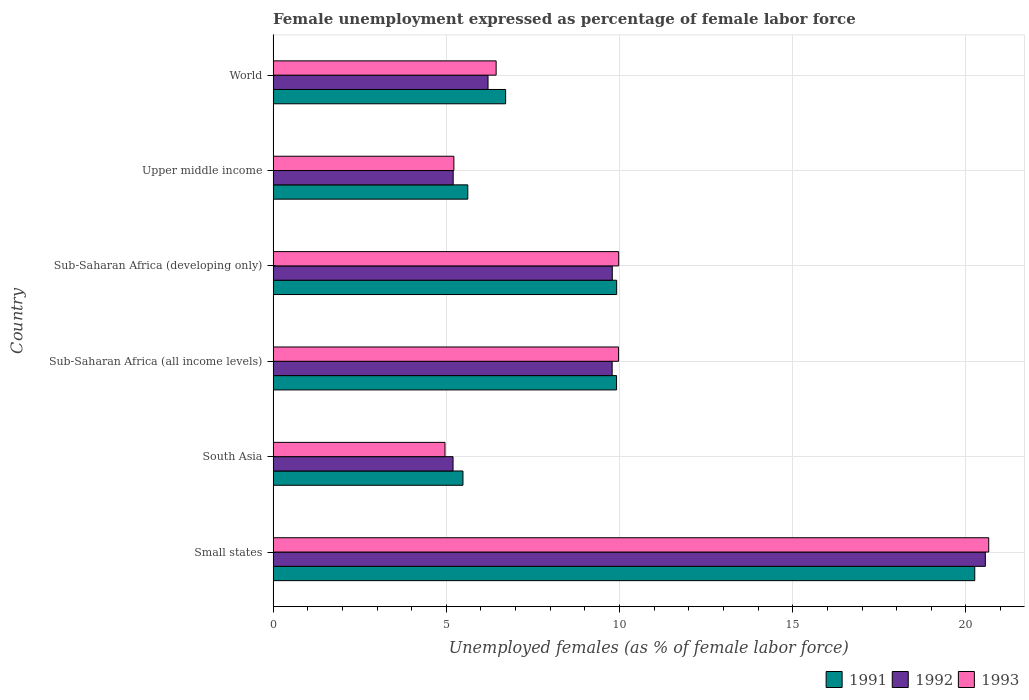Are the number of bars per tick equal to the number of legend labels?
Make the answer very short. Yes. How many bars are there on the 1st tick from the top?
Your response must be concise. 3. What is the label of the 5th group of bars from the top?
Provide a succinct answer. South Asia. In how many cases, is the number of bars for a given country not equal to the number of legend labels?
Your answer should be compact. 0. What is the unemployment in females in in 1991 in Sub-Saharan Africa (all income levels)?
Give a very brief answer. 9.91. Across all countries, what is the maximum unemployment in females in in 1992?
Keep it short and to the point. 20.56. Across all countries, what is the minimum unemployment in females in in 1993?
Offer a terse response. 4.96. In which country was the unemployment in females in in 1991 maximum?
Provide a short and direct response. Small states. What is the total unemployment in females in in 1993 in the graph?
Give a very brief answer. 57.22. What is the difference between the unemployment in females in in 1991 in South Asia and that in Sub-Saharan Africa (all income levels)?
Your response must be concise. -4.43. What is the difference between the unemployment in females in in 1993 in South Asia and the unemployment in females in in 1992 in World?
Your response must be concise. -1.24. What is the average unemployment in females in in 1993 per country?
Ensure brevity in your answer.  9.54. What is the difference between the unemployment in females in in 1993 and unemployment in females in in 1992 in Sub-Saharan Africa (all income levels)?
Your answer should be compact. 0.18. What is the ratio of the unemployment in females in in 1991 in Small states to that in Upper middle income?
Provide a short and direct response. 3.6. Is the unemployment in females in in 1993 in Sub-Saharan Africa (all income levels) less than that in Sub-Saharan Africa (developing only)?
Provide a short and direct response. Yes. What is the difference between the highest and the second highest unemployment in females in in 1993?
Give a very brief answer. 10.68. What is the difference between the highest and the lowest unemployment in females in in 1993?
Your response must be concise. 15.7. In how many countries, is the unemployment in females in in 1991 greater than the average unemployment in females in in 1991 taken over all countries?
Keep it short and to the point. 3. Is the sum of the unemployment in females in in 1991 in Sub-Saharan Africa (all income levels) and World greater than the maximum unemployment in females in in 1992 across all countries?
Provide a short and direct response. No. How many bars are there?
Offer a very short reply. 18. Are all the bars in the graph horizontal?
Ensure brevity in your answer.  Yes. What is the difference between two consecutive major ticks on the X-axis?
Offer a terse response. 5. Where does the legend appear in the graph?
Make the answer very short. Bottom right. How are the legend labels stacked?
Your answer should be very brief. Horizontal. What is the title of the graph?
Ensure brevity in your answer.  Female unemployment expressed as percentage of female labor force. Does "1992" appear as one of the legend labels in the graph?
Your answer should be compact. Yes. What is the label or title of the X-axis?
Your response must be concise. Unemployed females (as % of female labor force). What is the Unemployed females (as % of female labor force) of 1991 in Small states?
Your answer should be very brief. 20.25. What is the Unemployed females (as % of female labor force) of 1992 in Small states?
Make the answer very short. 20.56. What is the Unemployed females (as % of female labor force) in 1993 in Small states?
Your response must be concise. 20.66. What is the Unemployed females (as % of female labor force) in 1991 in South Asia?
Your answer should be very brief. 5.48. What is the Unemployed females (as % of female labor force) of 1992 in South Asia?
Keep it short and to the point. 5.19. What is the Unemployed females (as % of female labor force) in 1993 in South Asia?
Your answer should be very brief. 4.96. What is the Unemployed females (as % of female labor force) of 1991 in Sub-Saharan Africa (all income levels)?
Provide a short and direct response. 9.91. What is the Unemployed females (as % of female labor force) of 1992 in Sub-Saharan Africa (all income levels)?
Make the answer very short. 9.79. What is the Unemployed females (as % of female labor force) of 1993 in Sub-Saharan Africa (all income levels)?
Make the answer very short. 9.97. What is the Unemployed females (as % of female labor force) in 1991 in Sub-Saharan Africa (developing only)?
Offer a very short reply. 9.92. What is the Unemployed females (as % of female labor force) in 1992 in Sub-Saharan Africa (developing only)?
Give a very brief answer. 9.79. What is the Unemployed females (as % of female labor force) in 1993 in Sub-Saharan Africa (developing only)?
Make the answer very short. 9.98. What is the Unemployed females (as % of female labor force) of 1991 in Upper middle income?
Make the answer very short. 5.62. What is the Unemployed females (as % of female labor force) of 1992 in Upper middle income?
Your response must be concise. 5.2. What is the Unemployed females (as % of female labor force) of 1993 in Upper middle income?
Your response must be concise. 5.22. What is the Unemployed females (as % of female labor force) of 1991 in World?
Make the answer very short. 6.71. What is the Unemployed females (as % of female labor force) of 1992 in World?
Your answer should be very brief. 6.2. What is the Unemployed females (as % of female labor force) of 1993 in World?
Provide a short and direct response. 6.44. Across all countries, what is the maximum Unemployed females (as % of female labor force) of 1991?
Your response must be concise. 20.25. Across all countries, what is the maximum Unemployed females (as % of female labor force) in 1992?
Keep it short and to the point. 20.56. Across all countries, what is the maximum Unemployed females (as % of female labor force) of 1993?
Your answer should be compact. 20.66. Across all countries, what is the minimum Unemployed females (as % of female labor force) in 1991?
Keep it short and to the point. 5.48. Across all countries, what is the minimum Unemployed females (as % of female labor force) of 1992?
Your answer should be compact. 5.19. Across all countries, what is the minimum Unemployed females (as % of female labor force) of 1993?
Keep it short and to the point. 4.96. What is the total Unemployed females (as % of female labor force) in 1991 in the graph?
Your answer should be compact. 57.9. What is the total Unemployed females (as % of female labor force) of 1992 in the graph?
Your answer should be very brief. 56.73. What is the total Unemployed females (as % of female labor force) of 1993 in the graph?
Make the answer very short. 57.22. What is the difference between the Unemployed females (as % of female labor force) in 1991 in Small states and that in South Asia?
Ensure brevity in your answer.  14.77. What is the difference between the Unemployed females (as % of female labor force) in 1992 in Small states and that in South Asia?
Keep it short and to the point. 15.37. What is the difference between the Unemployed females (as % of female labor force) of 1993 in Small states and that in South Asia?
Provide a short and direct response. 15.7. What is the difference between the Unemployed females (as % of female labor force) in 1991 in Small states and that in Sub-Saharan Africa (all income levels)?
Offer a terse response. 10.34. What is the difference between the Unemployed females (as % of female labor force) in 1992 in Small states and that in Sub-Saharan Africa (all income levels)?
Ensure brevity in your answer.  10.77. What is the difference between the Unemployed females (as % of female labor force) of 1993 in Small states and that in Sub-Saharan Africa (all income levels)?
Provide a succinct answer. 10.69. What is the difference between the Unemployed females (as % of female labor force) of 1991 in Small states and that in Sub-Saharan Africa (developing only)?
Offer a terse response. 10.34. What is the difference between the Unemployed females (as % of female labor force) in 1992 in Small states and that in Sub-Saharan Africa (developing only)?
Provide a succinct answer. 10.77. What is the difference between the Unemployed females (as % of female labor force) in 1993 in Small states and that in Sub-Saharan Africa (developing only)?
Keep it short and to the point. 10.68. What is the difference between the Unemployed females (as % of female labor force) in 1991 in Small states and that in Upper middle income?
Your response must be concise. 14.63. What is the difference between the Unemployed females (as % of female labor force) in 1992 in Small states and that in Upper middle income?
Your answer should be very brief. 15.36. What is the difference between the Unemployed females (as % of female labor force) in 1993 in Small states and that in Upper middle income?
Offer a very short reply. 15.44. What is the difference between the Unemployed females (as % of female labor force) of 1991 in Small states and that in World?
Provide a short and direct response. 13.54. What is the difference between the Unemployed females (as % of female labor force) of 1992 in Small states and that in World?
Provide a succinct answer. 14.36. What is the difference between the Unemployed females (as % of female labor force) in 1993 in Small states and that in World?
Give a very brief answer. 14.22. What is the difference between the Unemployed females (as % of female labor force) of 1991 in South Asia and that in Sub-Saharan Africa (all income levels)?
Your answer should be compact. -4.43. What is the difference between the Unemployed females (as % of female labor force) of 1992 in South Asia and that in Sub-Saharan Africa (all income levels)?
Offer a terse response. -4.59. What is the difference between the Unemployed females (as % of female labor force) in 1993 in South Asia and that in Sub-Saharan Africa (all income levels)?
Keep it short and to the point. -5.01. What is the difference between the Unemployed females (as % of female labor force) in 1991 in South Asia and that in Sub-Saharan Africa (developing only)?
Offer a very short reply. -4.44. What is the difference between the Unemployed females (as % of female labor force) in 1992 in South Asia and that in Sub-Saharan Africa (developing only)?
Provide a succinct answer. -4.6. What is the difference between the Unemployed females (as % of female labor force) of 1993 in South Asia and that in Sub-Saharan Africa (developing only)?
Provide a succinct answer. -5.01. What is the difference between the Unemployed females (as % of female labor force) in 1991 in South Asia and that in Upper middle income?
Make the answer very short. -0.14. What is the difference between the Unemployed females (as % of female labor force) in 1992 in South Asia and that in Upper middle income?
Keep it short and to the point. -0. What is the difference between the Unemployed females (as % of female labor force) of 1993 in South Asia and that in Upper middle income?
Offer a terse response. -0.26. What is the difference between the Unemployed females (as % of female labor force) of 1991 in South Asia and that in World?
Your answer should be compact. -1.23. What is the difference between the Unemployed females (as % of female labor force) in 1992 in South Asia and that in World?
Offer a terse response. -1.01. What is the difference between the Unemployed females (as % of female labor force) of 1993 in South Asia and that in World?
Provide a short and direct response. -1.48. What is the difference between the Unemployed females (as % of female labor force) in 1991 in Sub-Saharan Africa (all income levels) and that in Sub-Saharan Africa (developing only)?
Give a very brief answer. -0. What is the difference between the Unemployed females (as % of female labor force) in 1992 in Sub-Saharan Africa (all income levels) and that in Sub-Saharan Africa (developing only)?
Your answer should be very brief. -0. What is the difference between the Unemployed females (as % of female labor force) in 1993 in Sub-Saharan Africa (all income levels) and that in Sub-Saharan Africa (developing only)?
Ensure brevity in your answer.  -0. What is the difference between the Unemployed females (as % of female labor force) of 1991 in Sub-Saharan Africa (all income levels) and that in Upper middle income?
Provide a short and direct response. 4.29. What is the difference between the Unemployed females (as % of female labor force) of 1992 in Sub-Saharan Africa (all income levels) and that in Upper middle income?
Your answer should be compact. 4.59. What is the difference between the Unemployed females (as % of female labor force) in 1993 in Sub-Saharan Africa (all income levels) and that in Upper middle income?
Your response must be concise. 4.75. What is the difference between the Unemployed females (as % of female labor force) of 1991 in Sub-Saharan Africa (all income levels) and that in World?
Ensure brevity in your answer.  3.2. What is the difference between the Unemployed females (as % of female labor force) of 1992 in Sub-Saharan Africa (all income levels) and that in World?
Your response must be concise. 3.58. What is the difference between the Unemployed females (as % of female labor force) of 1993 in Sub-Saharan Africa (all income levels) and that in World?
Offer a terse response. 3.53. What is the difference between the Unemployed females (as % of female labor force) of 1991 in Sub-Saharan Africa (developing only) and that in Upper middle income?
Offer a very short reply. 4.3. What is the difference between the Unemployed females (as % of female labor force) of 1992 in Sub-Saharan Africa (developing only) and that in Upper middle income?
Make the answer very short. 4.59. What is the difference between the Unemployed females (as % of female labor force) in 1993 in Sub-Saharan Africa (developing only) and that in Upper middle income?
Provide a short and direct response. 4.76. What is the difference between the Unemployed females (as % of female labor force) of 1991 in Sub-Saharan Africa (developing only) and that in World?
Ensure brevity in your answer.  3.21. What is the difference between the Unemployed females (as % of female labor force) in 1992 in Sub-Saharan Africa (developing only) and that in World?
Your answer should be very brief. 3.59. What is the difference between the Unemployed females (as % of female labor force) in 1993 in Sub-Saharan Africa (developing only) and that in World?
Your response must be concise. 3.54. What is the difference between the Unemployed females (as % of female labor force) in 1991 in Upper middle income and that in World?
Your response must be concise. -1.09. What is the difference between the Unemployed females (as % of female labor force) in 1992 in Upper middle income and that in World?
Your answer should be very brief. -1.01. What is the difference between the Unemployed females (as % of female labor force) in 1993 in Upper middle income and that in World?
Offer a terse response. -1.22. What is the difference between the Unemployed females (as % of female labor force) of 1991 in Small states and the Unemployed females (as % of female labor force) of 1992 in South Asia?
Keep it short and to the point. 15.06. What is the difference between the Unemployed females (as % of female labor force) of 1991 in Small states and the Unemployed females (as % of female labor force) of 1993 in South Asia?
Keep it short and to the point. 15.29. What is the difference between the Unemployed females (as % of female labor force) of 1992 in Small states and the Unemployed females (as % of female labor force) of 1993 in South Asia?
Make the answer very short. 15.6. What is the difference between the Unemployed females (as % of female labor force) of 1991 in Small states and the Unemployed females (as % of female labor force) of 1992 in Sub-Saharan Africa (all income levels)?
Your answer should be compact. 10.47. What is the difference between the Unemployed females (as % of female labor force) of 1991 in Small states and the Unemployed females (as % of female labor force) of 1993 in Sub-Saharan Africa (all income levels)?
Make the answer very short. 10.28. What is the difference between the Unemployed females (as % of female labor force) in 1992 in Small states and the Unemployed females (as % of female labor force) in 1993 in Sub-Saharan Africa (all income levels)?
Provide a succinct answer. 10.59. What is the difference between the Unemployed females (as % of female labor force) of 1991 in Small states and the Unemployed females (as % of female labor force) of 1992 in Sub-Saharan Africa (developing only)?
Provide a succinct answer. 10.46. What is the difference between the Unemployed females (as % of female labor force) in 1991 in Small states and the Unemployed females (as % of female labor force) in 1993 in Sub-Saharan Africa (developing only)?
Provide a short and direct response. 10.28. What is the difference between the Unemployed females (as % of female labor force) in 1992 in Small states and the Unemployed females (as % of female labor force) in 1993 in Sub-Saharan Africa (developing only)?
Your answer should be very brief. 10.58. What is the difference between the Unemployed females (as % of female labor force) of 1991 in Small states and the Unemployed females (as % of female labor force) of 1992 in Upper middle income?
Give a very brief answer. 15.06. What is the difference between the Unemployed females (as % of female labor force) in 1991 in Small states and the Unemployed females (as % of female labor force) in 1993 in Upper middle income?
Provide a short and direct response. 15.04. What is the difference between the Unemployed females (as % of female labor force) of 1992 in Small states and the Unemployed females (as % of female labor force) of 1993 in Upper middle income?
Provide a succinct answer. 15.34. What is the difference between the Unemployed females (as % of female labor force) in 1991 in Small states and the Unemployed females (as % of female labor force) in 1992 in World?
Keep it short and to the point. 14.05. What is the difference between the Unemployed females (as % of female labor force) in 1991 in Small states and the Unemployed females (as % of female labor force) in 1993 in World?
Your answer should be very brief. 13.82. What is the difference between the Unemployed females (as % of female labor force) in 1992 in Small states and the Unemployed females (as % of female labor force) in 1993 in World?
Keep it short and to the point. 14.12. What is the difference between the Unemployed females (as % of female labor force) of 1991 in South Asia and the Unemployed females (as % of female labor force) of 1992 in Sub-Saharan Africa (all income levels)?
Your response must be concise. -4.31. What is the difference between the Unemployed females (as % of female labor force) of 1991 in South Asia and the Unemployed females (as % of female labor force) of 1993 in Sub-Saharan Africa (all income levels)?
Ensure brevity in your answer.  -4.49. What is the difference between the Unemployed females (as % of female labor force) of 1992 in South Asia and the Unemployed females (as % of female labor force) of 1993 in Sub-Saharan Africa (all income levels)?
Offer a very short reply. -4.78. What is the difference between the Unemployed females (as % of female labor force) of 1991 in South Asia and the Unemployed females (as % of female labor force) of 1992 in Sub-Saharan Africa (developing only)?
Offer a terse response. -4.31. What is the difference between the Unemployed females (as % of female labor force) in 1991 in South Asia and the Unemployed females (as % of female labor force) in 1993 in Sub-Saharan Africa (developing only)?
Your response must be concise. -4.5. What is the difference between the Unemployed females (as % of female labor force) of 1992 in South Asia and the Unemployed females (as % of female labor force) of 1993 in Sub-Saharan Africa (developing only)?
Your answer should be very brief. -4.78. What is the difference between the Unemployed females (as % of female labor force) of 1991 in South Asia and the Unemployed females (as % of female labor force) of 1992 in Upper middle income?
Provide a succinct answer. 0.28. What is the difference between the Unemployed females (as % of female labor force) of 1991 in South Asia and the Unemployed females (as % of female labor force) of 1993 in Upper middle income?
Your response must be concise. 0.26. What is the difference between the Unemployed females (as % of female labor force) in 1992 in South Asia and the Unemployed females (as % of female labor force) in 1993 in Upper middle income?
Make the answer very short. -0.02. What is the difference between the Unemployed females (as % of female labor force) of 1991 in South Asia and the Unemployed females (as % of female labor force) of 1992 in World?
Your answer should be very brief. -0.72. What is the difference between the Unemployed females (as % of female labor force) of 1991 in South Asia and the Unemployed females (as % of female labor force) of 1993 in World?
Your answer should be compact. -0.96. What is the difference between the Unemployed females (as % of female labor force) in 1992 in South Asia and the Unemployed females (as % of female labor force) in 1993 in World?
Your response must be concise. -1.24. What is the difference between the Unemployed females (as % of female labor force) in 1991 in Sub-Saharan Africa (all income levels) and the Unemployed females (as % of female labor force) in 1992 in Sub-Saharan Africa (developing only)?
Your answer should be very brief. 0.12. What is the difference between the Unemployed females (as % of female labor force) in 1991 in Sub-Saharan Africa (all income levels) and the Unemployed females (as % of female labor force) in 1993 in Sub-Saharan Africa (developing only)?
Provide a succinct answer. -0.06. What is the difference between the Unemployed females (as % of female labor force) of 1992 in Sub-Saharan Africa (all income levels) and the Unemployed females (as % of female labor force) of 1993 in Sub-Saharan Africa (developing only)?
Give a very brief answer. -0.19. What is the difference between the Unemployed females (as % of female labor force) of 1991 in Sub-Saharan Africa (all income levels) and the Unemployed females (as % of female labor force) of 1992 in Upper middle income?
Offer a terse response. 4.72. What is the difference between the Unemployed females (as % of female labor force) in 1991 in Sub-Saharan Africa (all income levels) and the Unemployed females (as % of female labor force) in 1993 in Upper middle income?
Provide a short and direct response. 4.7. What is the difference between the Unemployed females (as % of female labor force) in 1992 in Sub-Saharan Africa (all income levels) and the Unemployed females (as % of female labor force) in 1993 in Upper middle income?
Your answer should be very brief. 4.57. What is the difference between the Unemployed females (as % of female labor force) of 1991 in Sub-Saharan Africa (all income levels) and the Unemployed females (as % of female labor force) of 1992 in World?
Provide a succinct answer. 3.71. What is the difference between the Unemployed females (as % of female labor force) of 1991 in Sub-Saharan Africa (all income levels) and the Unemployed females (as % of female labor force) of 1993 in World?
Offer a very short reply. 3.48. What is the difference between the Unemployed females (as % of female labor force) in 1992 in Sub-Saharan Africa (all income levels) and the Unemployed females (as % of female labor force) in 1993 in World?
Ensure brevity in your answer.  3.35. What is the difference between the Unemployed females (as % of female labor force) of 1991 in Sub-Saharan Africa (developing only) and the Unemployed females (as % of female labor force) of 1992 in Upper middle income?
Keep it short and to the point. 4.72. What is the difference between the Unemployed females (as % of female labor force) in 1991 in Sub-Saharan Africa (developing only) and the Unemployed females (as % of female labor force) in 1993 in Upper middle income?
Your answer should be compact. 4.7. What is the difference between the Unemployed females (as % of female labor force) in 1992 in Sub-Saharan Africa (developing only) and the Unemployed females (as % of female labor force) in 1993 in Upper middle income?
Make the answer very short. 4.57. What is the difference between the Unemployed females (as % of female labor force) in 1991 in Sub-Saharan Africa (developing only) and the Unemployed females (as % of female labor force) in 1992 in World?
Your answer should be very brief. 3.71. What is the difference between the Unemployed females (as % of female labor force) of 1991 in Sub-Saharan Africa (developing only) and the Unemployed females (as % of female labor force) of 1993 in World?
Your response must be concise. 3.48. What is the difference between the Unemployed females (as % of female labor force) in 1992 in Sub-Saharan Africa (developing only) and the Unemployed females (as % of female labor force) in 1993 in World?
Provide a short and direct response. 3.35. What is the difference between the Unemployed females (as % of female labor force) in 1991 in Upper middle income and the Unemployed females (as % of female labor force) in 1992 in World?
Ensure brevity in your answer.  -0.58. What is the difference between the Unemployed females (as % of female labor force) in 1991 in Upper middle income and the Unemployed females (as % of female labor force) in 1993 in World?
Offer a terse response. -0.82. What is the difference between the Unemployed females (as % of female labor force) of 1992 in Upper middle income and the Unemployed females (as % of female labor force) of 1993 in World?
Keep it short and to the point. -1.24. What is the average Unemployed females (as % of female labor force) of 1991 per country?
Ensure brevity in your answer.  9.65. What is the average Unemployed females (as % of female labor force) in 1992 per country?
Make the answer very short. 9.46. What is the average Unemployed females (as % of female labor force) in 1993 per country?
Your answer should be very brief. 9.54. What is the difference between the Unemployed females (as % of female labor force) in 1991 and Unemployed females (as % of female labor force) in 1992 in Small states?
Your answer should be compact. -0.31. What is the difference between the Unemployed females (as % of female labor force) in 1991 and Unemployed females (as % of female labor force) in 1993 in Small states?
Your response must be concise. -0.4. What is the difference between the Unemployed females (as % of female labor force) of 1992 and Unemployed females (as % of female labor force) of 1993 in Small states?
Offer a very short reply. -0.1. What is the difference between the Unemployed females (as % of female labor force) in 1991 and Unemployed females (as % of female labor force) in 1992 in South Asia?
Your answer should be compact. 0.29. What is the difference between the Unemployed females (as % of female labor force) in 1991 and Unemployed females (as % of female labor force) in 1993 in South Asia?
Provide a short and direct response. 0.52. What is the difference between the Unemployed females (as % of female labor force) of 1992 and Unemployed females (as % of female labor force) of 1993 in South Asia?
Offer a terse response. 0.23. What is the difference between the Unemployed females (as % of female labor force) of 1991 and Unemployed females (as % of female labor force) of 1992 in Sub-Saharan Africa (all income levels)?
Keep it short and to the point. 0.13. What is the difference between the Unemployed females (as % of female labor force) of 1991 and Unemployed females (as % of female labor force) of 1993 in Sub-Saharan Africa (all income levels)?
Your answer should be very brief. -0.06. What is the difference between the Unemployed females (as % of female labor force) in 1992 and Unemployed females (as % of female labor force) in 1993 in Sub-Saharan Africa (all income levels)?
Offer a terse response. -0.18. What is the difference between the Unemployed females (as % of female labor force) in 1991 and Unemployed females (as % of female labor force) in 1992 in Sub-Saharan Africa (developing only)?
Provide a succinct answer. 0.13. What is the difference between the Unemployed females (as % of female labor force) in 1991 and Unemployed females (as % of female labor force) in 1993 in Sub-Saharan Africa (developing only)?
Your response must be concise. -0.06. What is the difference between the Unemployed females (as % of female labor force) in 1992 and Unemployed females (as % of female labor force) in 1993 in Sub-Saharan Africa (developing only)?
Keep it short and to the point. -0.18. What is the difference between the Unemployed females (as % of female labor force) in 1991 and Unemployed females (as % of female labor force) in 1992 in Upper middle income?
Provide a succinct answer. 0.42. What is the difference between the Unemployed females (as % of female labor force) in 1991 and Unemployed females (as % of female labor force) in 1993 in Upper middle income?
Provide a succinct answer. 0.4. What is the difference between the Unemployed females (as % of female labor force) in 1992 and Unemployed females (as % of female labor force) in 1993 in Upper middle income?
Offer a very short reply. -0.02. What is the difference between the Unemployed females (as % of female labor force) in 1991 and Unemployed females (as % of female labor force) in 1992 in World?
Your answer should be very brief. 0.51. What is the difference between the Unemployed females (as % of female labor force) of 1991 and Unemployed females (as % of female labor force) of 1993 in World?
Make the answer very short. 0.27. What is the difference between the Unemployed females (as % of female labor force) in 1992 and Unemployed females (as % of female labor force) in 1993 in World?
Your answer should be very brief. -0.23. What is the ratio of the Unemployed females (as % of female labor force) of 1991 in Small states to that in South Asia?
Offer a very short reply. 3.7. What is the ratio of the Unemployed females (as % of female labor force) of 1992 in Small states to that in South Asia?
Make the answer very short. 3.96. What is the ratio of the Unemployed females (as % of female labor force) in 1993 in Small states to that in South Asia?
Provide a short and direct response. 4.16. What is the ratio of the Unemployed females (as % of female labor force) of 1991 in Small states to that in Sub-Saharan Africa (all income levels)?
Your answer should be very brief. 2.04. What is the ratio of the Unemployed females (as % of female labor force) of 1992 in Small states to that in Sub-Saharan Africa (all income levels)?
Offer a very short reply. 2.1. What is the ratio of the Unemployed females (as % of female labor force) in 1993 in Small states to that in Sub-Saharan Africa (all income levels)?
Your response must be concise. 2.07. What is the ratio of the Unemployed females (as % of female labor force) of 1991 in Small states to that in Sub-Saharan Africa (developing only)?
Give a very brief answer. 2.04. What is the ratio of the Unemployed females (as % of female labor force) of 1992 in Small states to that in Sub-Saharan Africa (developing only)?
Ensure brevity in your answer.  2.1. What is the ratio of the Unemployed females (as % of female labor force) of 1993 in Small states to that in Sub-Saharan Africa (developing only)?
Your answer should be very brief. 2.07. What is the ratio of the Unemployed females (as % of female labor force) of 1991 in Small states to that in Upper middle income?
Provide a succinct answer. 3.6. What is the ratio of the Unemployed females (as % of female labor force) in 1992 in Small states to that in Upper middle income?
Provide a short and direct response. 3.96. What is the ratio of the Unemployed females (as % of female labor force) of 1993 in Small states to that in Upper middle income?
Provide a short and direct response. 3.96. What is the ratio of the Unemployed females (as % of female labor force) of 1991 in Small states to that in World?
Your answer should be compact. 3.02. What is the ratio of the Unemployed females (as % of female labor force) of 1992 in Small states to that in World?
Offer a very short reply. 3.31. What is the ratio of the Unemployed females (as % of female labor force) of 1993 in Small states to that in World?
Offer a very short reply. 3.21. What is the ratio of the Unemployed females (as % of female labor force) of 1991 in South Asia to that in Sub-Saharan Africa (all income levels)?
Make the answer very short. 0.55. What is the ratio of the Unemployed females (as % of female labor force) of 1992 in South Asia to that in Sub-Saharan Africa (all income levels)?
Your answer should be very brief. 0.53. What is the ratio of the Unemployed females (as % of female labor force) of 1993 in South Asia to that in Sub-Saharan Africa (all income levels)?
Provide a succinct answer. 0.5. What is the ratio of the Unemployed females (as % of female labor force) of 1991 in South Asia to that in Sub-Saharan Africa (developing only)?
Ensure brevity in your answer.  0.55. What is the ratio of the Unemployed females (as % of female labor force) of 1992 in South Asia to that in Sub-Saharan Africa (developing only)?
Your response must be concise. 0.53. What is the ratio of the Unemployed females (as % of female labor force) in 1993 in South Asia to that in Sub-Saharan Africa (developing only)?
Offer a terse response. 0.5. What is the ratio of the Unemployed females (as % of female labor force) of 1991 in South Asia to that in Upper middle income?
Provide a succinct answer. 0.98. What is the ratio of the Unemployed females (as % of female labor force) of 1992 in South Asia to that in Upper middle income?
Offer a terse response. 1. What is the ratio of the Unemployed females (as % of female labor force) of 1993 in South Asia to that in Upper middle income?
Provide a short and direct response. 0.95. What is the ratio of the Unemployed females (as % of female labor force) of 1991 in South Asia to that in World?
Provide a short and direct response. 0.82. What is the ratio of the Unemployed females (as % of female labor force) of 1992 in South Asia to that in World?
Make the answer very short. 0.84. What is the ratio of the Unemployed females (as % of female labor force) of 1993 in South Asia to that in World?
Offer a very short reply. 0.77. What is the ratio of the Unemployed females (as % of female labor force) of 1991 in Sub-Saharan Africa (all income levels) to that in Sub-Saharan Africa (developing only)?
Offer a very short reply. 1. What is the ratio of the Unemployed females (as % of female labor force) of 1992 in Sub-Saharan Africa (all income levels) to that in Sub-Saharan Africa (developing only)?
Provide a succinct answer. 1. What is the ratio of the Unemployed females (as % of female labor force) in 1991 in Sub-Saharan Africa (all income levels) to that in Upper middle income?
Offer a terse response. 1.76. What is the ratio of the Unemployed females (as % of female labor force) in 1992 in Sub-Saharan Africa (all income levels) to that in Upper middle income?
Ensure brevity in your answer.  1.88. What is the ratio of the Unemployed females (as % of female labor force) of 1993 in Sub-Saharan Africa (all income levels) to that in Upper middle income?
Provide a short and direct response. 1.91. What is the ratio of the Unemployed females (as % of female labor force) in 1991 in Sub-Saharan Africa (all income levels) to that in World?
Provide a short and direct response. 1.48. What is the ratio of the Unemployed females (as % of female labor force) of 1992 in Sub-Saharan Africa (all income levels) to that in World?
Your response must be concise. 1.58. What is the ratio of the Unemployed females (as % of female labor force) of 1993 in Sub-Saharan Africa (all income levels) to that in World?
Keep it short and to the point. 1.55. What is the ratio of the Unemployed females (as % of female labor force) of 1991 in Sub-Saharan Africa (developing only) to that in Upper middle income?
Ensure brevity in your answer.  1.76. What is the ratio of the Unemployed females (as % of female labor force) of 1992 in Sub-Saharan Africa (developing only) to that in Upper middle income?
Give a very brief answer. 1.88. What is the ratio of the Unemployed females (as % of female labor force) in 1993 in Sub-Saharan Africa (developing only) to that in Upper middle income?
Make the answer very short. 1.91. What is the ratio of the Unemployed females (as % of female labor force) of 1991 in Sub-Saharan Africa (developing only) to that in World?
Provide a short and direct response. 1.48. What is the ratio of the Unemployed females (as % of female labor force) of 1992 in Sub-Saharan Africa (developing only) to that in World?
Keep it short and to the point. 1.58. What is the ratio of the Unemployed females (as % of female labor force) of 1993 in Sub-Saharan Africa (developing only) to that in World?
Your response must be concise. 1.55. What is the ratio of the Unemployed females (as % of female labor force) of 1991 in Upper middle income to that in World?
Make the answer very short. 0.84. What is the ratio of the Unemployed females (as % of female labor force) of 1992 in Upper middle income to that in World?
Your response must be concise. 0.84. What is the ratio of the Unemployed females (as % of female labor force) of 1993 in Upper middle income to that in World?
Provide a succinct answer. 0.81. What is the difference between the highest and the second highest Unemployed females (as % of female labor force) of 1991?
Ensure brevity in your answer.  10.34. What is the difference between the highest and the second highest Unemployed females (as % of female labor force) in 1992?
Give a very brief answer. 10.77. What is the difference between the highest and the second highest Unemployed females (as % of female labor force) of 1993?
Provide a short and direct response. 10.68. What is the difference between the highest and the lowest Unemployed females (as % of female labor force) of 1991?
Keep it short and to the point. 14.77. What is the difference between the highest and the lowest Unemployed females (as % of female labor force) in 1992?
Offer a terse response. 15.37. What is the difference between the highest and the lowest Unemployed females (as % of female labor force) of 1993?
Ensure brevity in your answer.  15.7. 